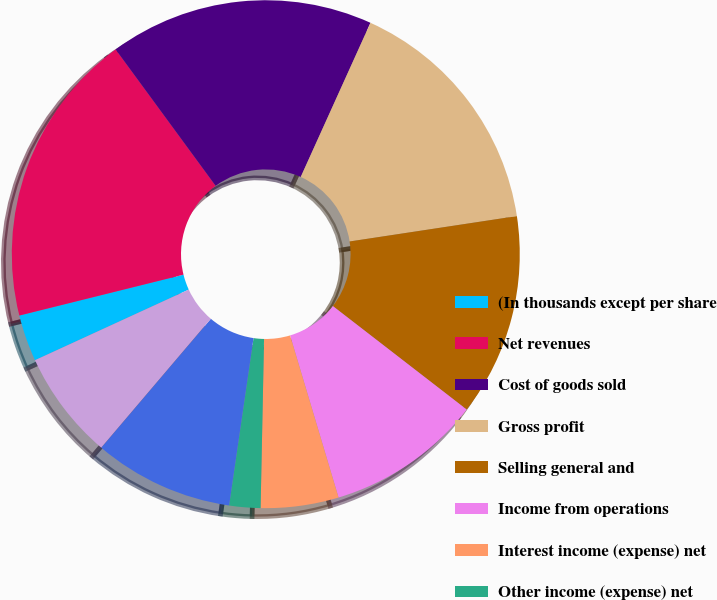<chart> <loc_0><loc_0><loc_500><loc_500><pie_chart><fcel>(In thousands except per share<fcel>Net revenues<fcel>Cost of goods sold<fcel>Gross profit<fcel>Selling general and<fcel>Income from operations<fcel>Interest income (expense) net<fcel>Other income (expense) net<fcel>Income before income taxes<fcel>Provision for income taxes<nl><fcel>2.97%<fcel>18.81%<fcel>16.83%<fcel>15.84%<fcel>12.87%<fcel>9.9%<fcel>4.95%<fcel>1.98%<fcel>8.91%<fcel>6.93%<nl></chart> 